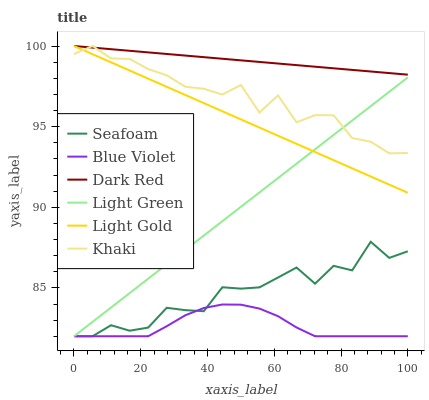Does Blue Violet have the minimum area under the curve?
Answer yes or no. Yes. Does Dark Red have the maximum area under the curve?
Answer yes or no. Yes. Does Seafoam have the minimum area under the curve?
Answer yes or no. No. Does Seafoam have the maximum area under the curve?
Answer yes or no. No. Is Light Green the smoothest?
Answer yes or no. Yes. Is Seafoam the roughest?
Answer yes or no. Yes. Is Dark Red the smoothest?
Answer yes or no. No. Is Dark Red the roughest?
Answer yes or no. No. Does Seafoam have the lowest value?
Answer yes or no. Yes. Does Dark Red have the lowest value?
Answer yes or no. No. Does Light Gold have the highest value?
Answer yes or no. Yes. Does Seafoam have the highest value?
Answer yes or no. No. Is Seafoam less than Light Gold?
Answer yes or no. Yes. Is Light Gold greater than Seafoam?
Answer yes or no. Yes. Does Khaki intersect Light Gold?
Answer yes or no. Yes. Is Khaki less than Light Gold?
Answer yes or no. No. Is Khaki greater than Light Gold?
Answer yes or no. No. Does Seafoam intersect Light Gold?
Answer yes or no. No. 